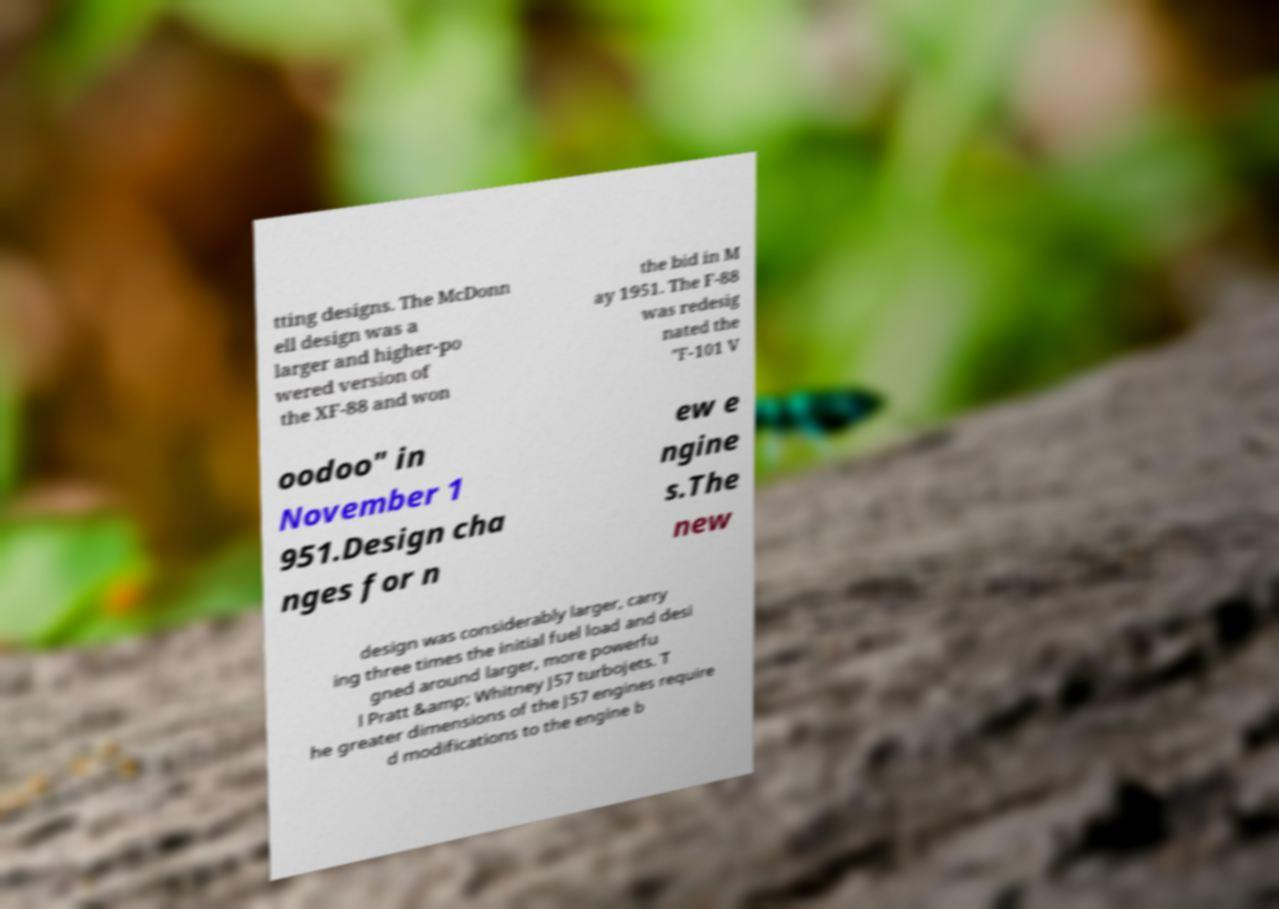There's text embedded in this image that I need extracted. Can you transcribe it verbatim? tting designs. The McDonn ell design was a larger and higher-po wered version of the XF-88 and won the bid in M ay 1951. The F-88 was redesig nated the "F-101 V oodoo" in November 1 951.Design cha nges for n ew e ngine s.The new design was considerably larger, carry ing three times the initial fuel load and desi gned around larger, more powerfu l Pratt &amp; Whitney J57 turbojets. T he greater dimensions of the J57 engines require d modifications to the engine b 